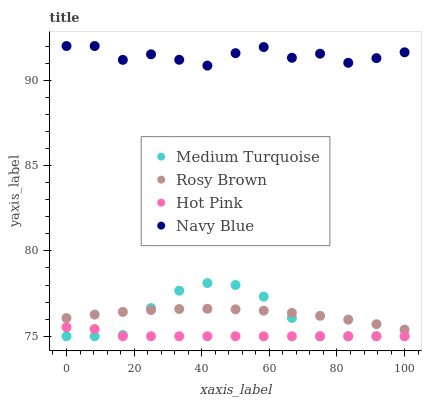Does Hot Pink have the minimum area under the curve?
Answer yes or no. Yes. Does Navy Blue have the maximum area under the curve?
Answer yes or no. Yes. Does Rosy Brown have the minimum area under the curve?
Answer yes or no. No. Does Rosy Brown have the maximum area under the curve?
Answer yes or no. No. Is Rosy Brown the smoothest?
Answer yes or no. Yes. Is Navy Blue the roughest?
Answer yes or no. Yes. Is Medium Turquoise the smoothest?
Answer yes or no. No. Is Medium Turquoise the roughest?
Answer yes or no. No. Does Medium Turquoise have the lowest value?
Answer yes or no. Yes. Does Rosy Brown have the lowest value?
Answer yes or no. No. Does Navy Blue have the highest value?
Answer yes or no. Yes. Does Rosy Brown have the highest value?
Answer yes or no. No. Is Rosy Brown less than Navy Blue?
Answer yes or no. Yes. Is Rosy Brown greater than Hot Pink?
Answer yes or no. Yes. Does Medium Turquoise intersect Hot Pink?
Answer yes or no. Yes. Is Medium Turquoise less than Hot Pink?
Answer yes or no. No. Is Medium Turquoise greater than Hot Pink?
Answer yes or no. No. Does Rosy Brown intersect Navy Blue?
Answer yes or no. No. 